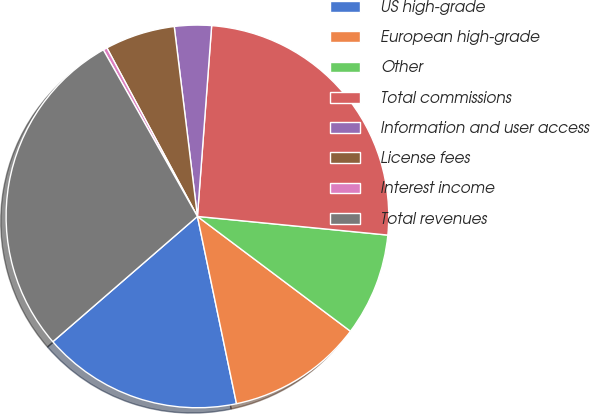<chart> <loc_0><loc_0><loc_500><loc_500><pie_chart><fcel>US high-grade<fcel>European high-grade<fcel>Other<fcel>Total commissions<fcel>Information and user access<fcel>License fees<fcel>Interest income<fcel>Total revenues<nl><fcel>16.91%<fcel>11.48%<fcel>8.69%<fcel>25.37%<fcel>3.12%<fcel>5.91%<fcel>0.34%<fcel>28.18%<nl></chart> 